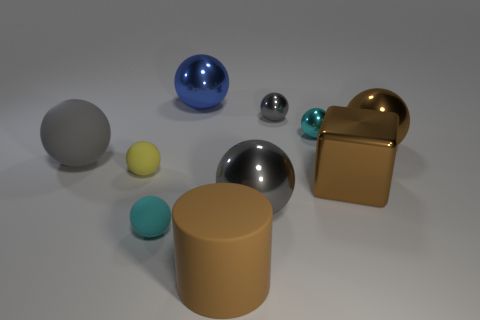How many cyan spheres must be subtracted to get 1 cyan spheres? 1 Subtract all brown spheres. How many spheres are left? 7 Subtract all cyan balls. How many balls are left? 6 Subtract all cubes. How many objects are left? 9 Subtract 1 cylinders. How many cylinders are left? 0 Subtract all brown shiny spheres. Subtract all big matte balls. How many objects are left? 8 Add 3 small spheres. How many small spheres are left? 7 Add 9 blue metal blocks. How many blue metal blocks exist? 9 Subtract 0 red balls. How many objects are left? 10 Subtract all green cubes. Subtract all cyan cylinders. How many cubes are left? 1 